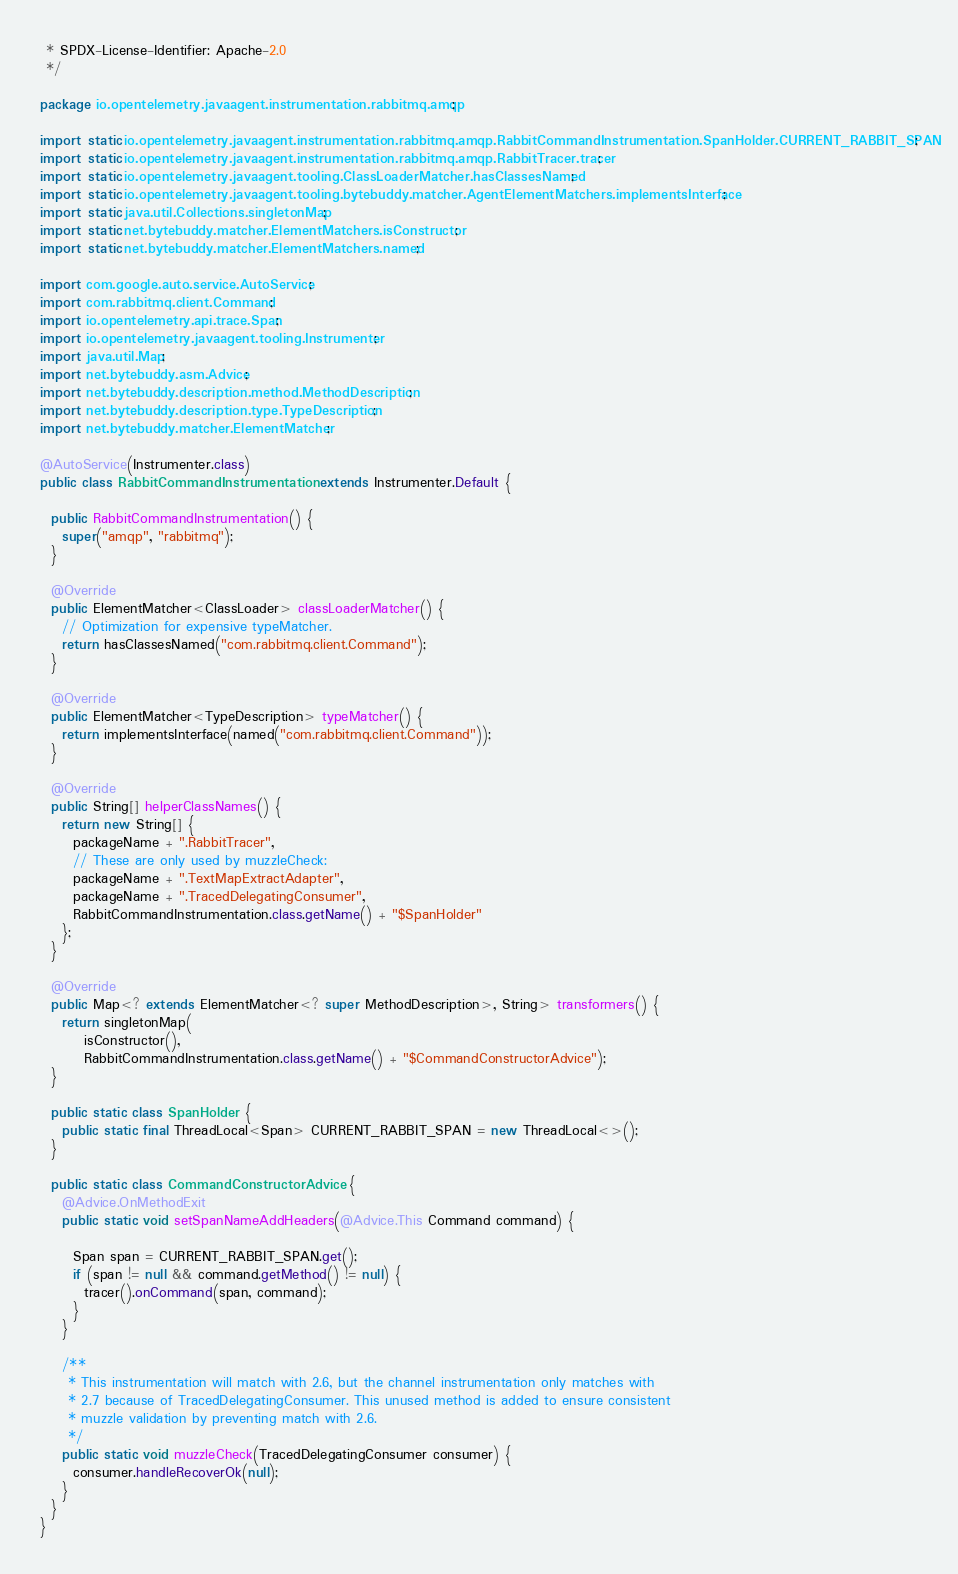Convert code to text. <code><loc_0><loc_0><loc_500><loc_500><_Java_> * SPDX-License-Identifier: Apache-2.0
 */

package io.opentelemetry.javaagent.instrumentation.rabbitmq.amqp;

import static io.opentelemetry.javaagent.instrumentation.rabbitmq.amqp.RabbitCommandInstrumentation.SpanHolder.CURRENT_RABBIT_SPAN;
import static io.opentelemetry.javaagent.instrumentation.rabbitmq.amqp.RabbitTracer.tracer;
import static io.opentelemetry.javaagent.tooling.ClassLoaderMatcher.hasClassesNamed;
import static io.opentelemetry.javaagent.tooling.bytebuddy.matcher.AgentElementMatchers.implementsInterface;
import static java.util.Collections.singletonMap;
import static net.bytebuddy.matcher.ElementMatchers.isConstructor;
import static net.bytebuddy.matcher.ElementMatchers.named;

import com.google.auto.service.AutoService;
import com.rabbitmq.client.Command;
import io.opentelemetry.api.trace.Span;
import io.opentelemetry.javaagent.tooling.Instrumenter;
import java.util.Map;
import net.bytebuddy.asm.Advice;
import net.bytebuddy.description.method.MethodDescription;
import net.bytebuddy.description.type.TypeDescription;
import net.bytebuddy.matcher.ElementMatcher;

@AutoService(Instrumenter.class)
public class RabbitCommandInstrumentation extends Instrumenter.Default {

  public RabbitCommandInstrumentation() {
    super("amqp", "rabbitmq");
  }

  @Override
  public ElementMatcher<ClassLoader> classLoaderMatcher() {
    // Optimization for expensive typeMatcher.
    return hasClassesNamed("com.rabbitmq.client.Command");
  }

  @Override
  public ElementMatcher<TypeDescription> typeMatcher() {
    return implementsInterface(named("com.rabbitmq.client.Command"));
  }

  @Override
  public String[] helperClassNames() {
    return new String[] {
      packageName + ".RabbitTracer",
      // These are only used by muzzleCheck:
      packageName + ".TextMapExtractAdapter",
      packageName + ".TracedDelegatingConsumer",
      RabbitCommandInstrumentation.class.getName() + "$SpanHolder"
    };
  }

  @Override
  public Map<? extends ElementMatcher<? super MethodDescription>, String> transformers() {
    return singletonMap(
        isConstructor(),
        RabbitCommandInstrumentation.class.getName() + "$CommandConstructorAdvice");
  }

  public static class SpanHolder {
    public static final ThreadLocal<Span> CURRENT_RABBIT_SPAN = new ThreadLocal<>();
  }

  public static class CommandConstructorAdvice {
    @Advice.OnMethodExit
    public static void setSpanNameAddHeaders(@Advice.This Command command) {

      Span span = CURRENT_RABBIT_SPAN.get();
      if (span != null && command.getMethod() != null) {
        tracer().onCommand(span, command);
      }
    }

    /**
     * This instrumentation will match with 2.6, but the channel instrumentation only matches with
     * 2.7 because of TracedDelegatingConsumer. This unused method is added to ensure consistent
     * muzzle validation by preventing match with 2.6.
     */
    public static void muzzleCheck(TracedDelegatingConsumer consumer) {
      consumer.handleRecoverOk(null);
    }
  }
}
</code> 